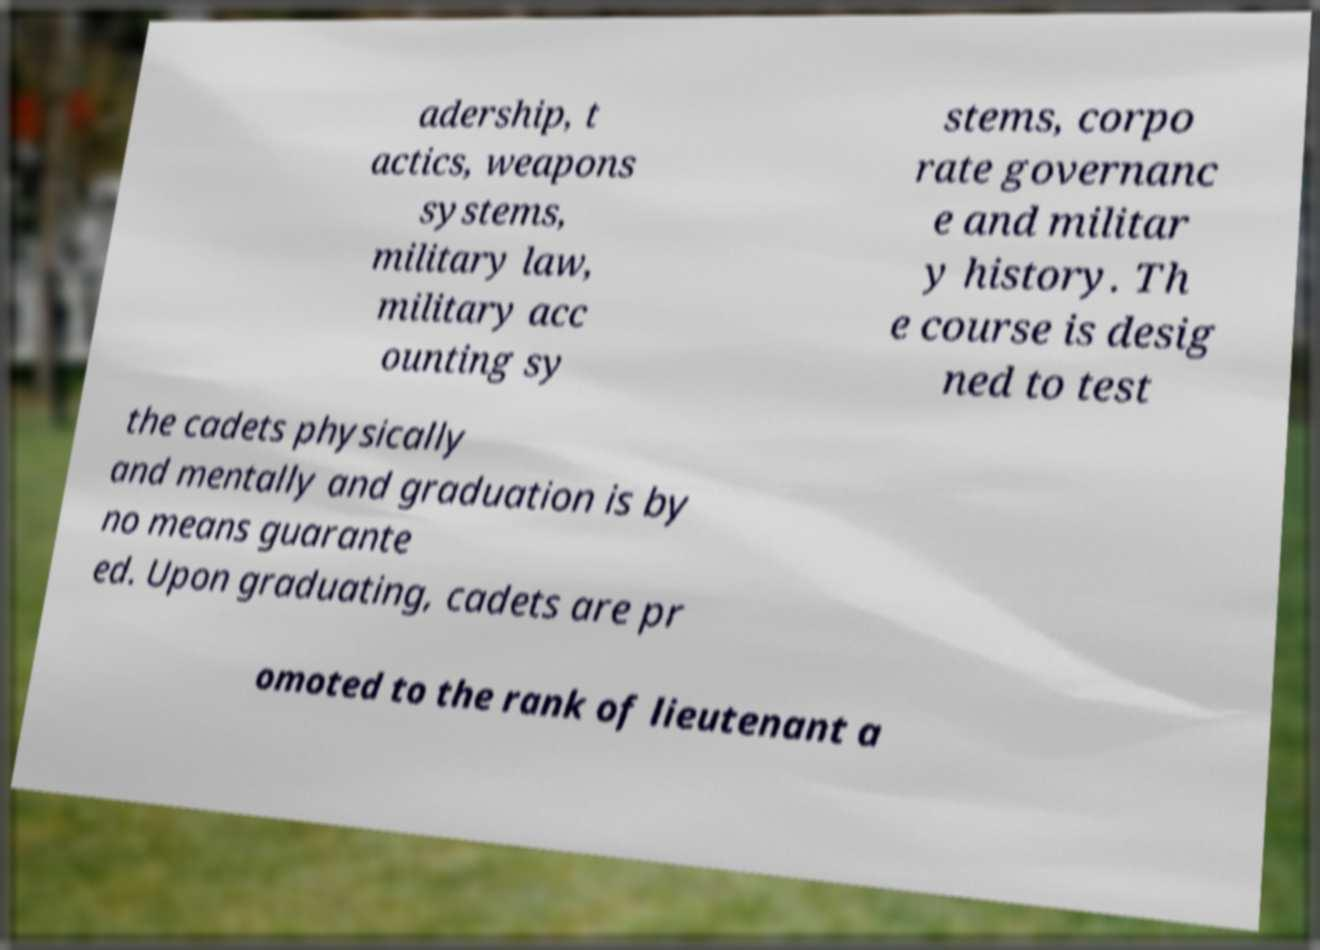I need the written content from this picture converted into text. Can you do that? adership, t actics, weapons systems, military law, military acc ounting sy stems, corpo rate governanc e and militar y history. Th e course is desig ned to test the cadets physically and mentally and graduation is by no means guarante ed. Upon graduating, cadets are pr omoted to the rank of lieutenant a 